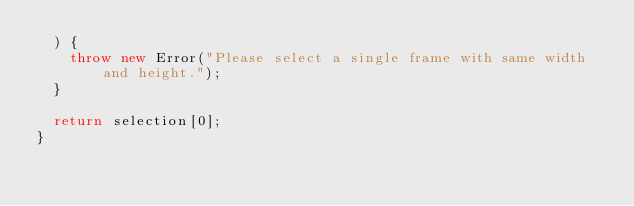<code> <loc_0><loc_0><loc_500><loc_500><_TypeScript_>  ) {
    throw new Error("Please select a single frame with same width and height.");
  }

  return selection[0];
}
</code> 